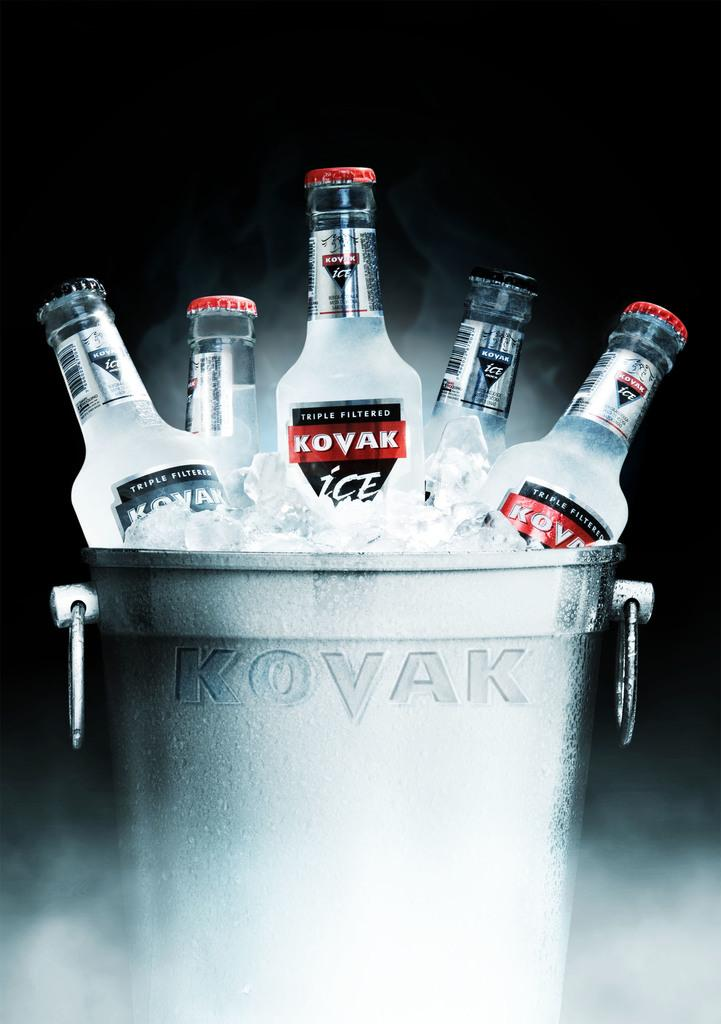<image>
Offer a succinct explanation of the picture presented. A metal bucket that stamped with the brand Kovak, filled with ice and 5 bottles of Kovak Ice. 